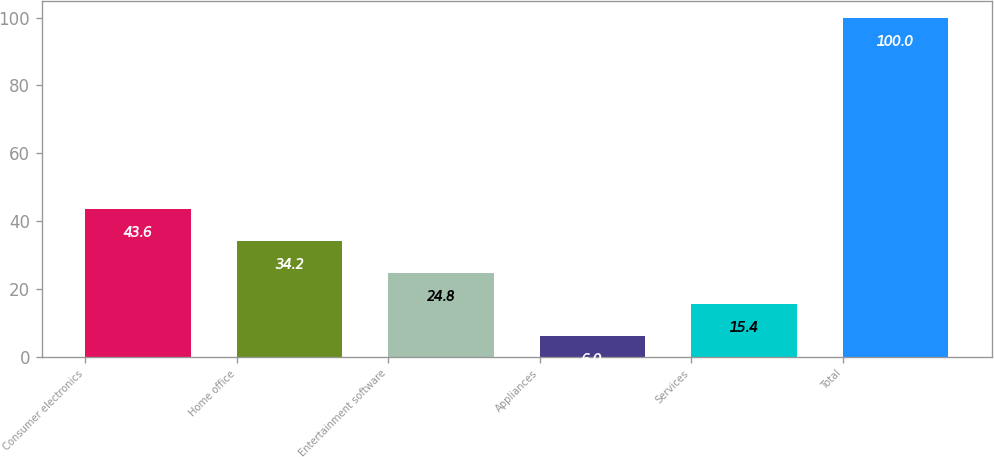<chart> <loc_0><loc_0><loc_500><loc_500><bar_chart><fcel>Consumer electronics<fcel>Home office<fcel>Entertainment software<fcel>Appliances<fcel>Services<fcel>Total<nl><fcel>43.6<fcel>34.2<fcel>24.8<fcel>6<fcel>15.4<fcel>100<nl></chart> 